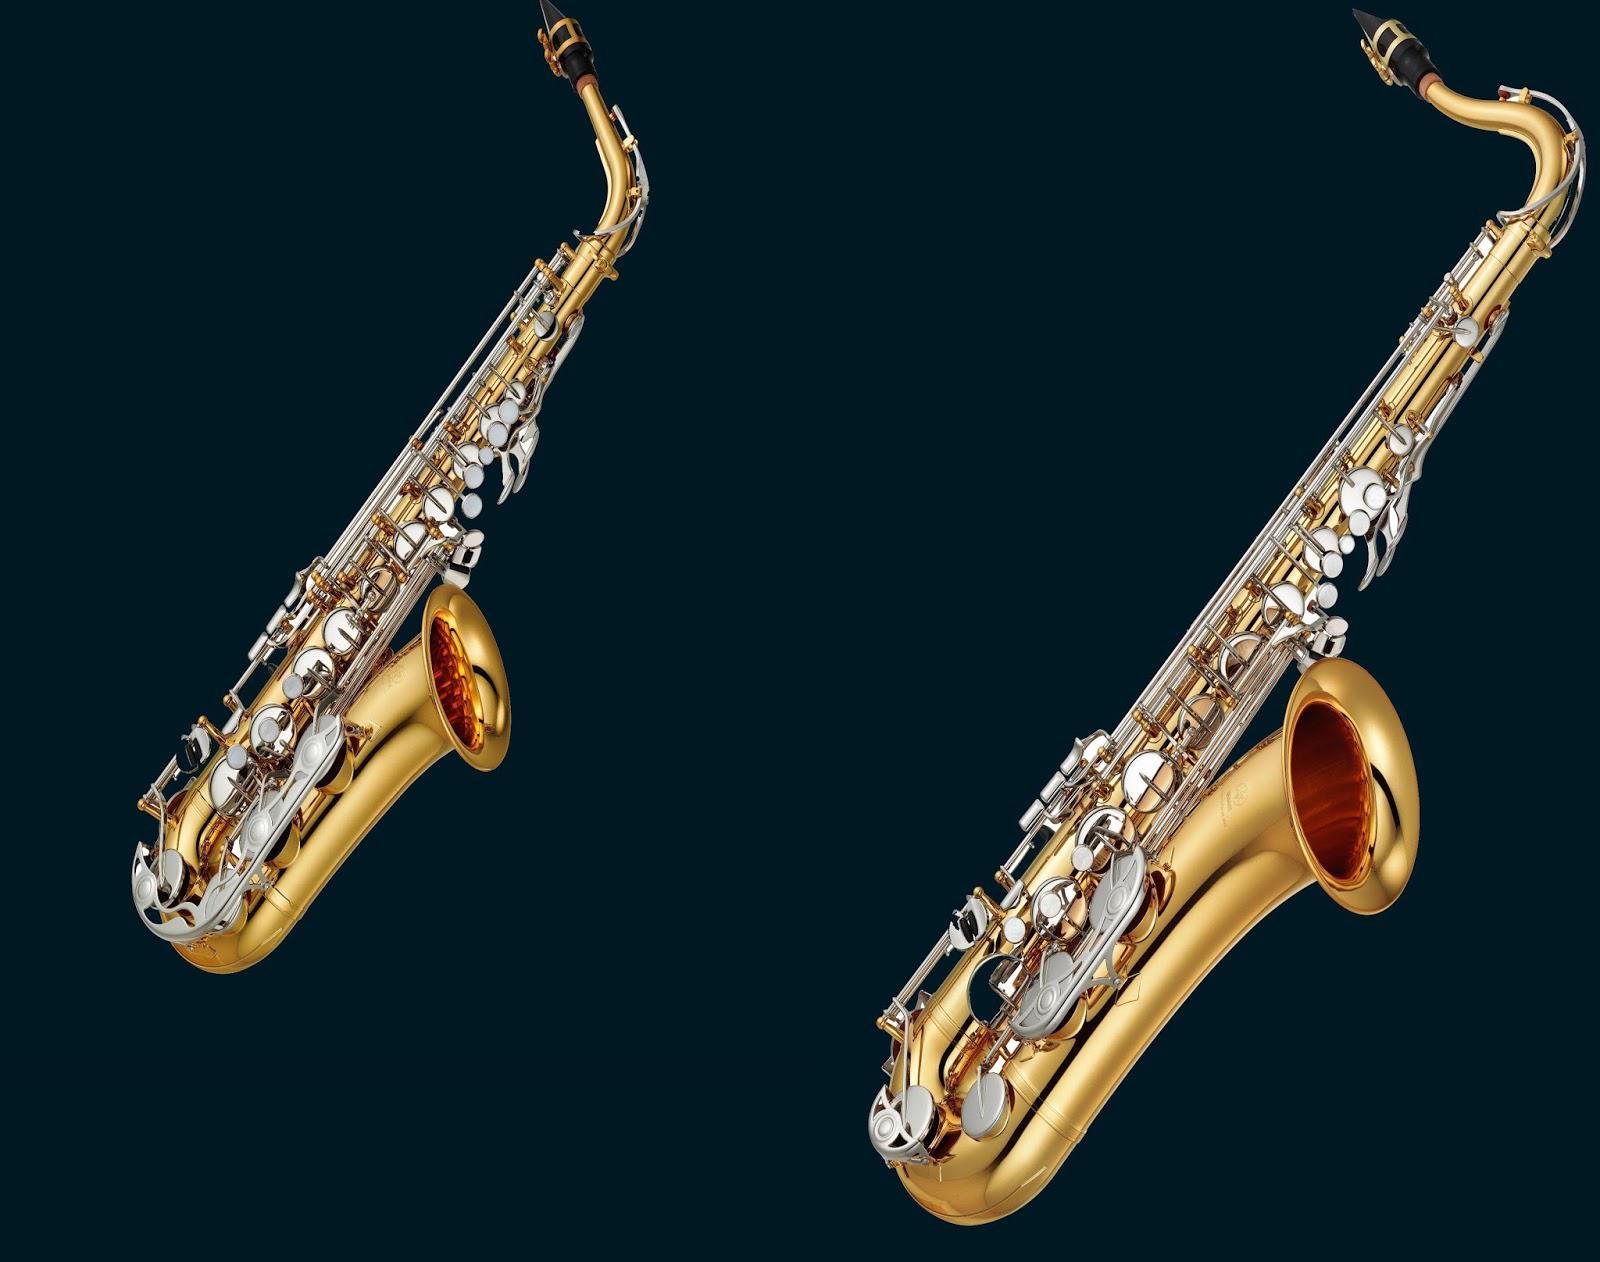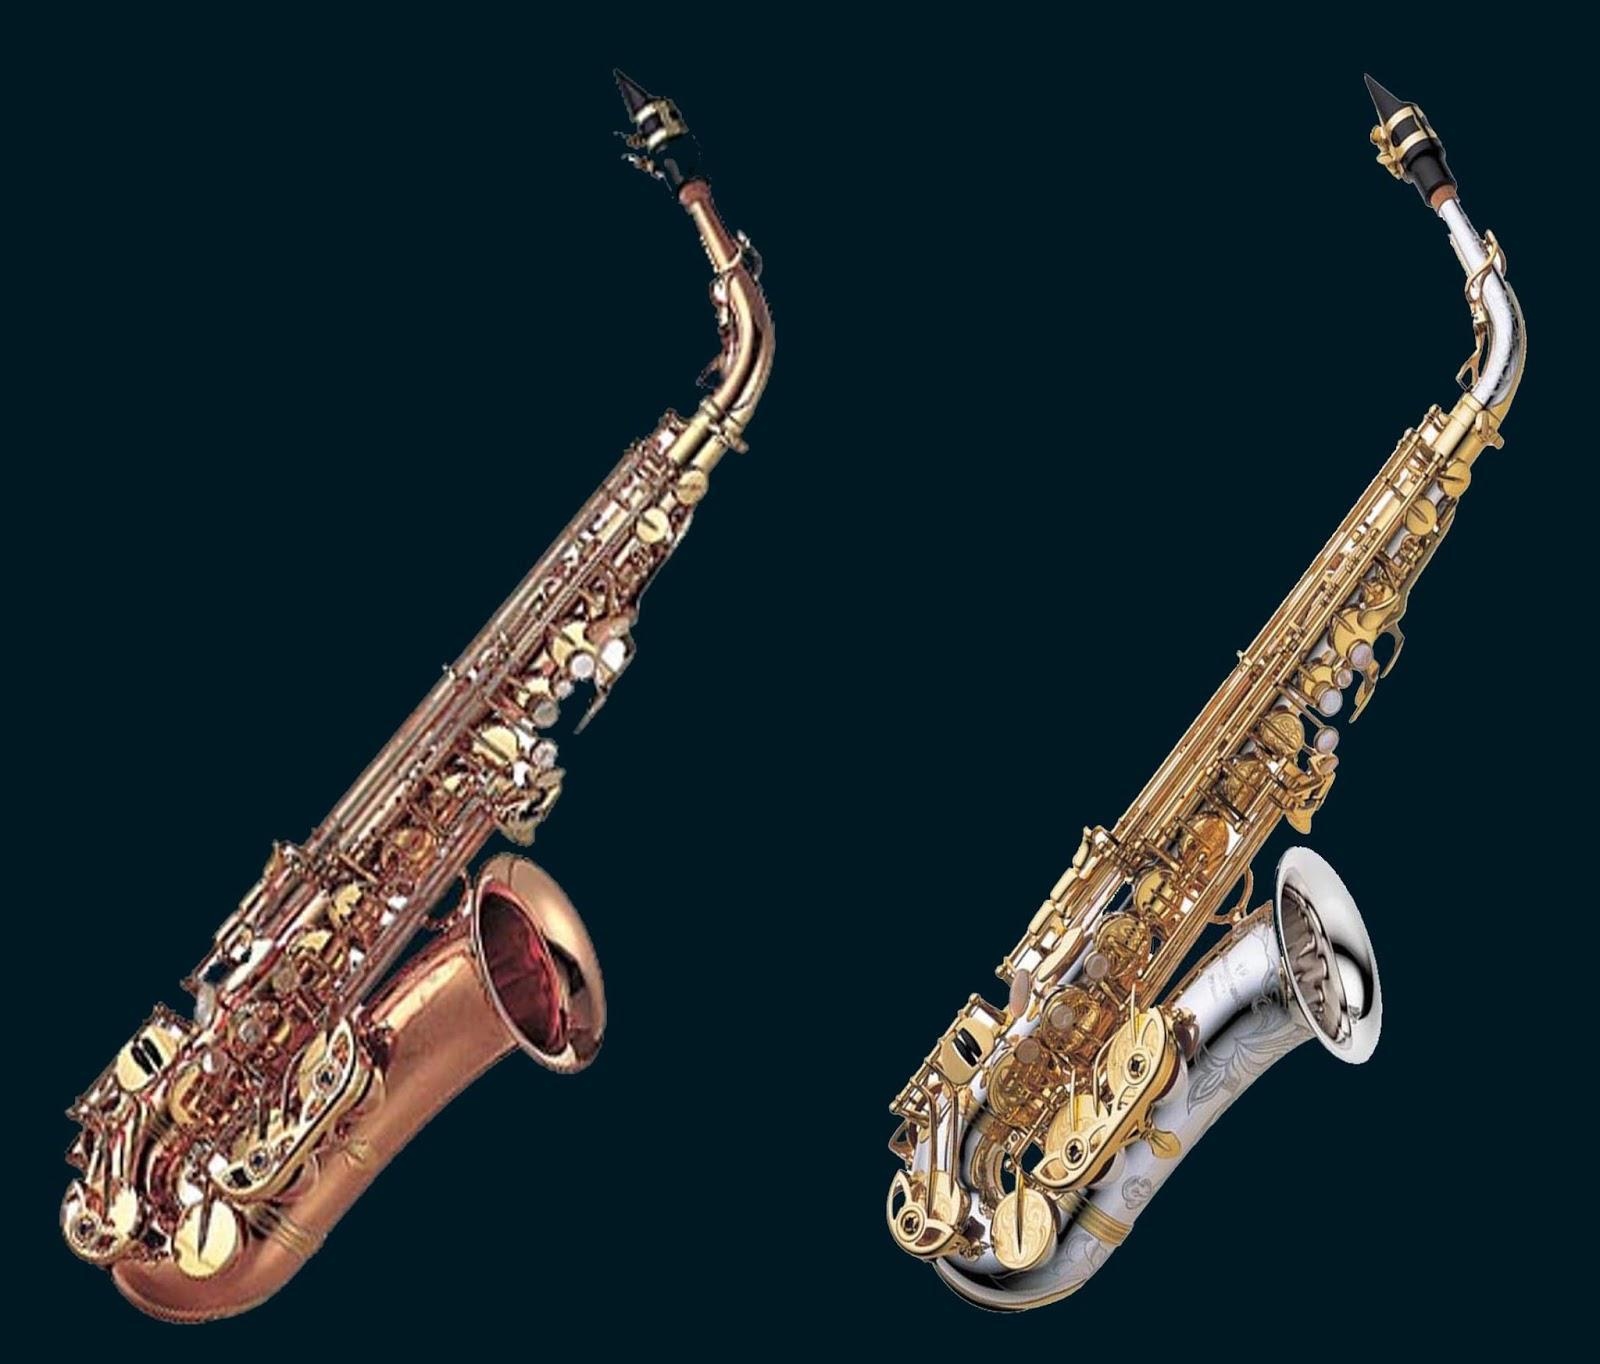The first image is the image on the left, the second image is the image on the right. Assess this claim about the two images: "There are no more than 3 saxophones.". Correct or not? Answer yes or no. No. 